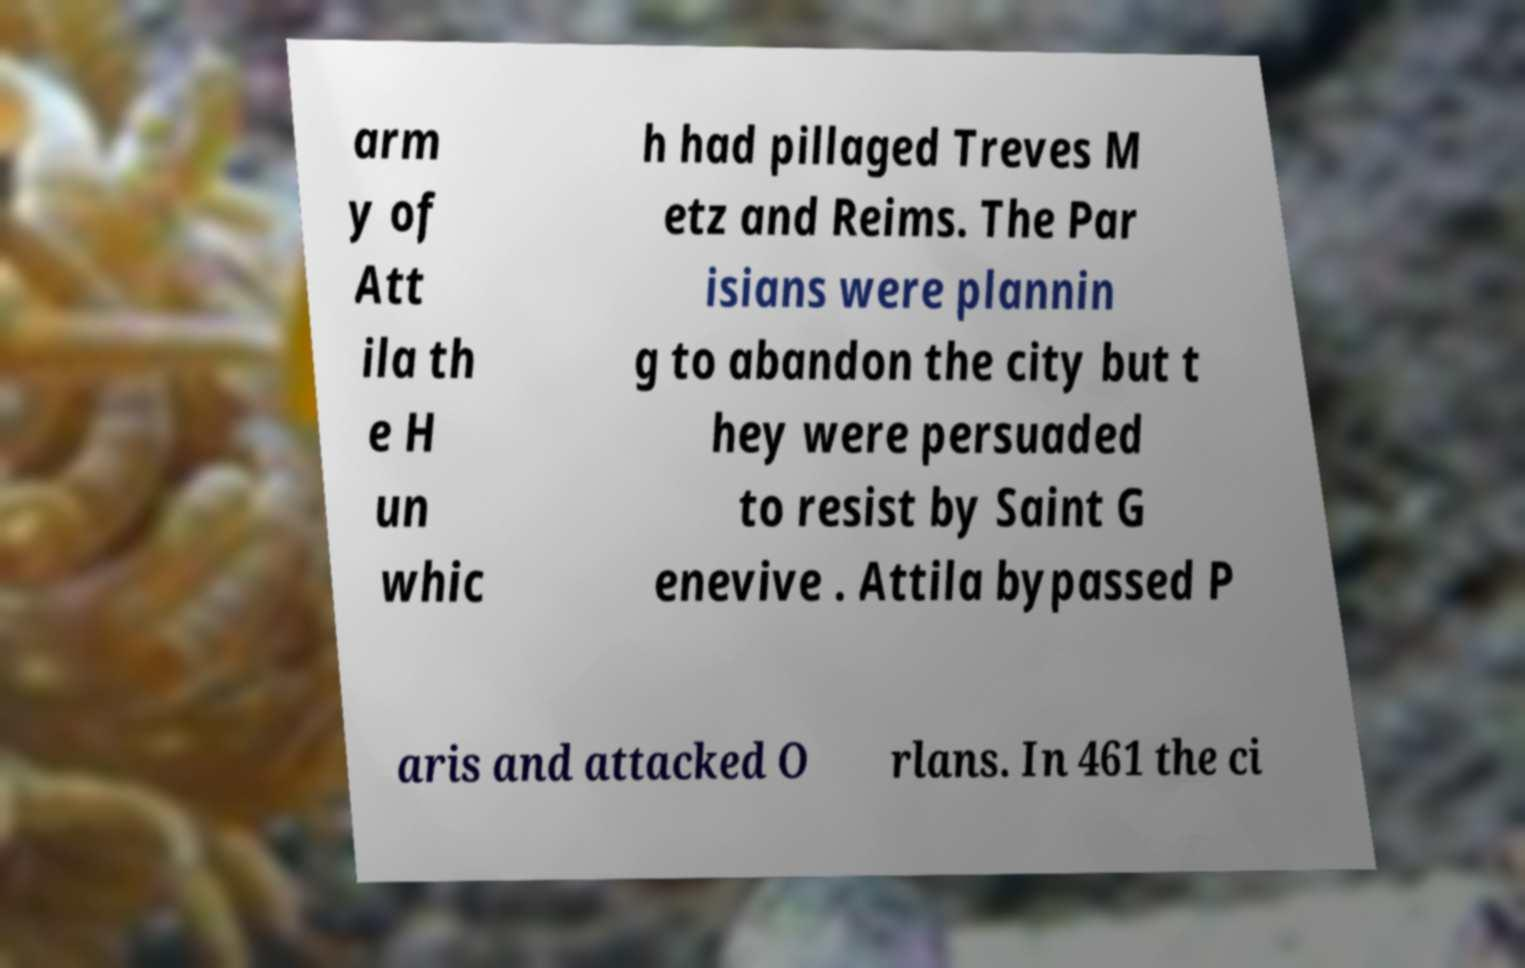Please identify and transcribe the text found in this image. arm y of Att ila th e H un whic h had pillaged Treves M etz and Reims. The Par isians were plannin g to abandon the city but t hey were persuaded to resist by Saint G enevive . Attila bypassed P aris and attacked O rlans. In 461 the ci 